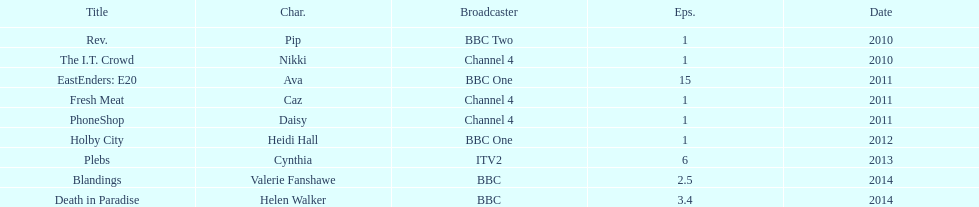What is the total number of shows sophie colguhoun appeared in? 9. 